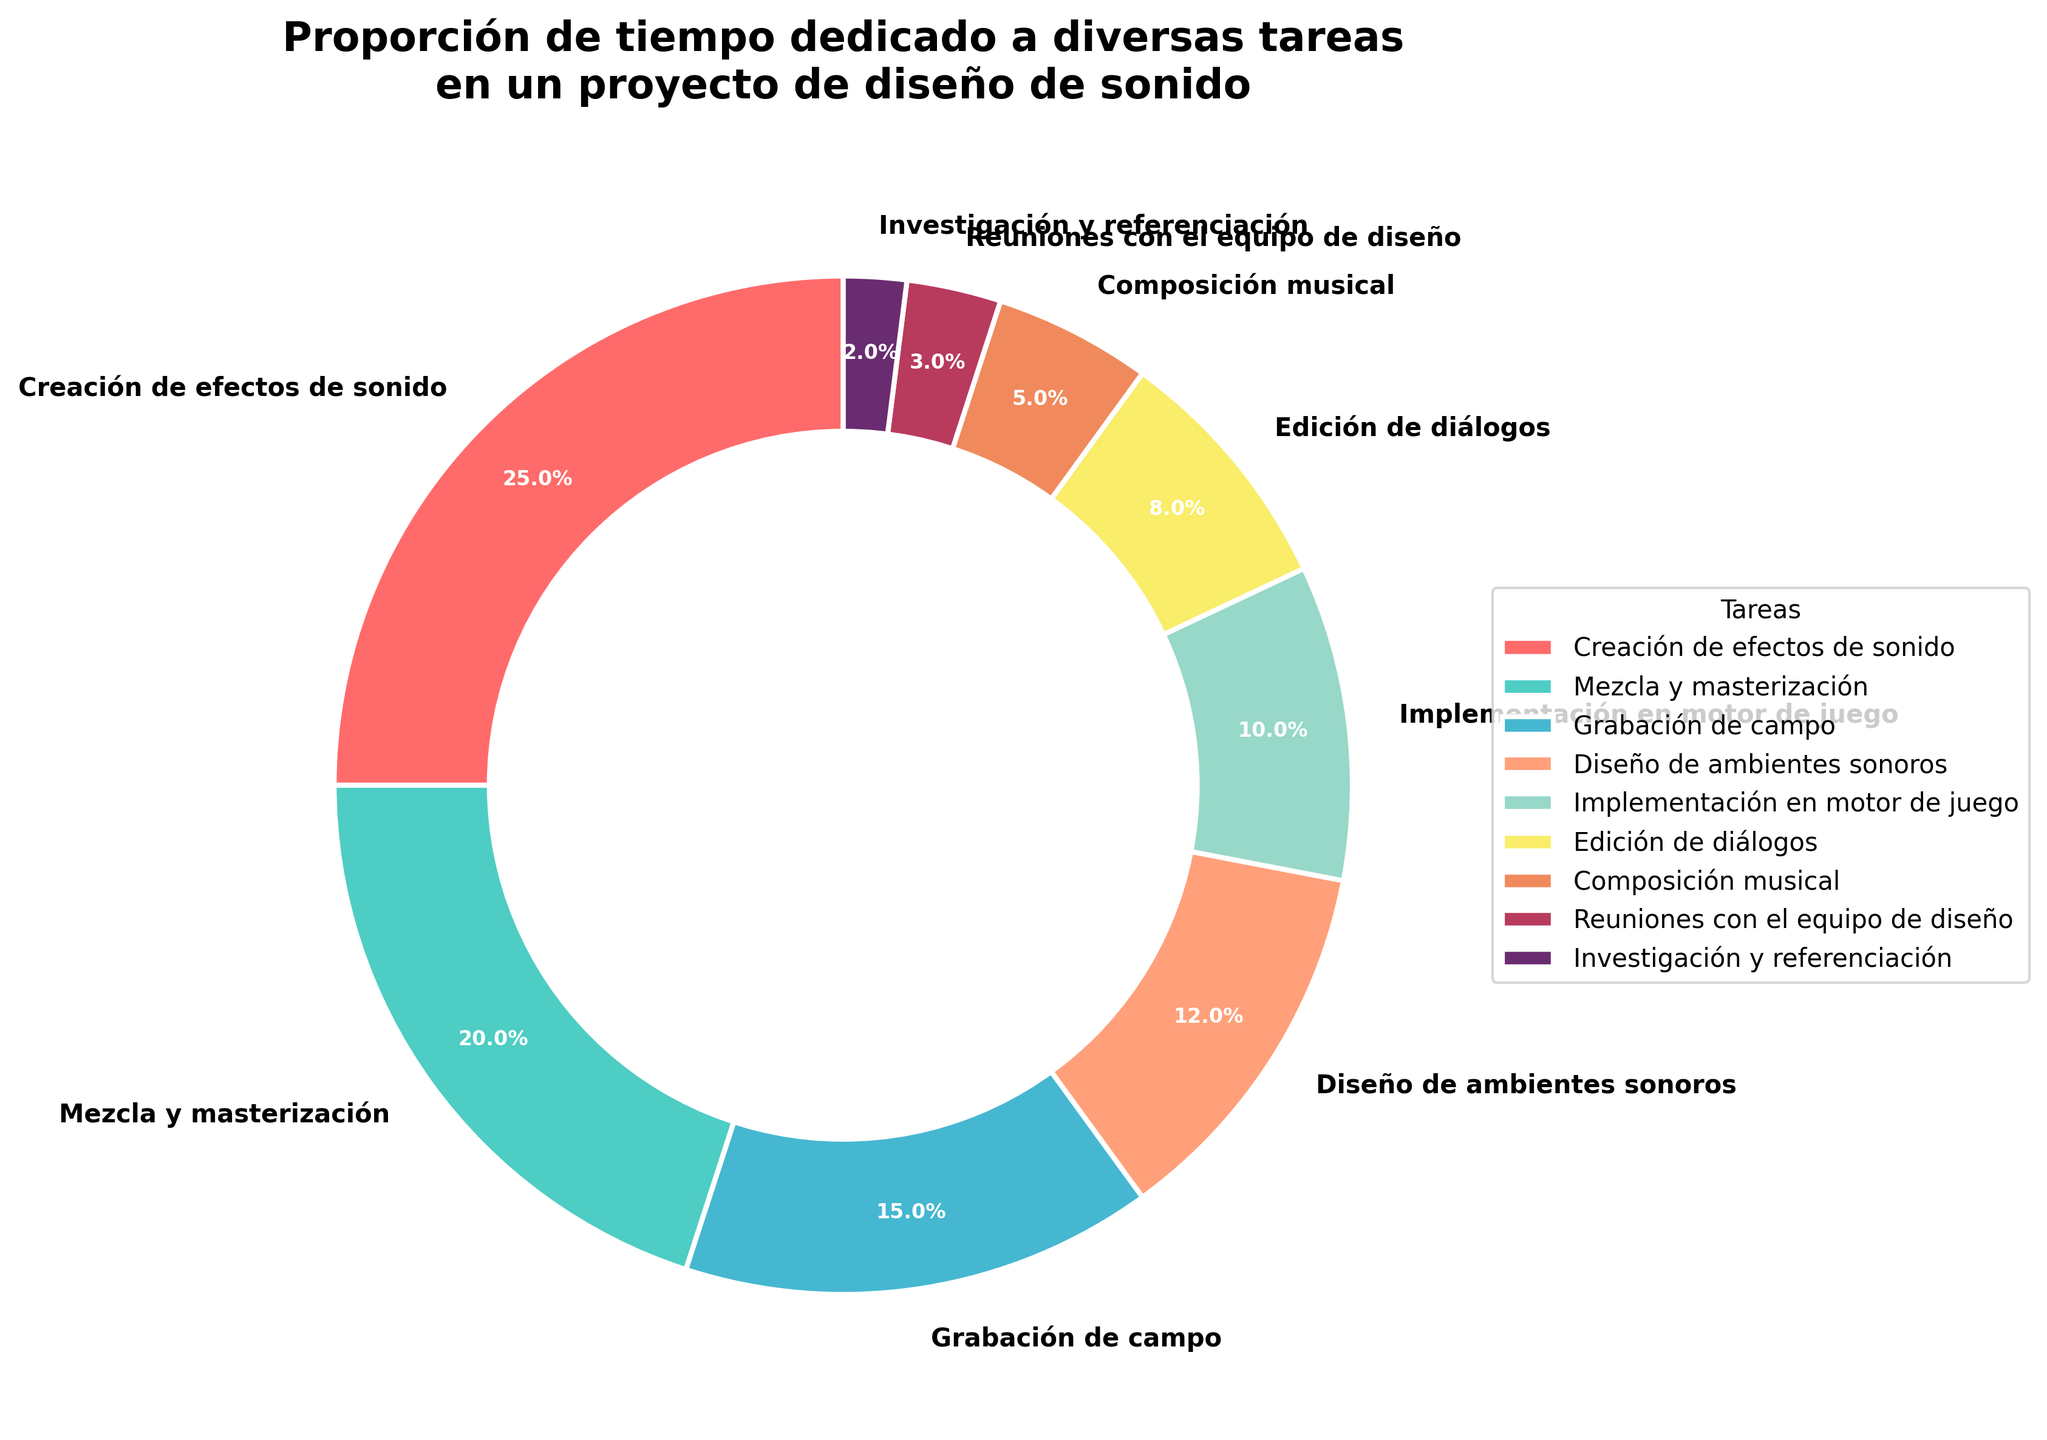¿Cuál tarea ocupa el mayor porcentaje de tiempo? Observamos la gráfica y notamos que el segmento más grande corresponde a la creación de efectos de sonido, que tiene el 25%
Answer: Creación de efectos de sonido ¿Cuántas tareas requieren más del 15% del tiempo total? Contamos los segmentos con un porcentaje mayor al 15%. Son dos: creación de efectos de sonido (25%) y mezcla y masterización (20%)
Answer: 2 ¿La grabación de campo ocupa más o menos tiempo que la implementación en el motor de juego? Comparamos los porcentajes: grabación de campo tiene 15% y la implementación en el motor de juego tiene 10%, por lo cual la grabación de campo ocupa más tiempo
Answer: Más Cuando sumamos el porcentaje de tiempo dedicado al diseño de ambientes sonoros y la composición musical, ¿cuál es el resultado? Sumamos sus porcentajes: 12% (diseño de ambientes sonoros) + 5% (composición musical) = 17%
Answer: 17% ¿Cuál es el color correspondiente a la edición de diálogos? Encontramos la sección de la edición de diálogos en la gráfica, la cual es de color rojo
Answer: Rojo ¿Cuánto tiempo en total se dedica a las reuniones con el equipo de diseño y a la investigación y referenciación? Sumamos los porcentajes de ambas tareas: 3% (reuniones con el equipo de diseño) + 2% (investigación y referenciación) = 5%
Answer: 5% ¿Es cierto que la mezcla y masterización ocupa más tiempo que la implementación en el motor de juego y la edición de diálogos juntas? Sumamos los porcentajes de la implementación en el motor de juego (10%) y la edición de diálogos (8%) y comparamos con la mezcla y masterización (20%): 10% + 8% = 18%, que es menor que 20%
Answer: Sí ¿Cuál es el segundo segmento más pequeño en la gráfica? Miramos los segmentos y ordenamos: investigación y referenciación es el más pequeño (2%) y reuniones con el equipo de diseño es el segundo más pequeño (3%)
Answer: Reuniones con el equipo de diseño De estas dos categorías, ¿cuál ocupa más tiempo: diseño de ambientes sonoros o edición de diálogos? Comparamos los porcentajes: diseño de ambientes sonoros (12%) y edición de diálogos (8%), el diseño de ambientes sonoros ocupa más tiempo
Answer: Diseño de ambientes sonoros 